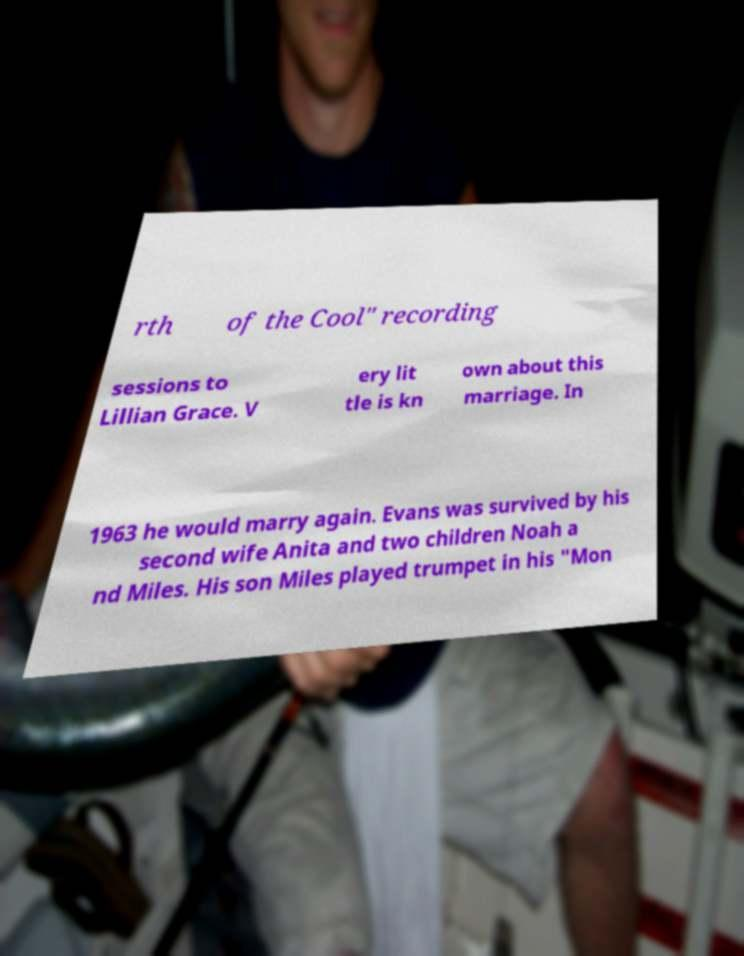Could you assist in decoding the text presented in this image and type it out clearly? rth of the Cool" recording sessions to Lillian Grace. V ery lit tle is kn own about this marriage. In 1963 he would marry again. Evans was survived by his second wife Anita and two children Noah a nd Miles. His son Miles played trumpet in his "Mon 